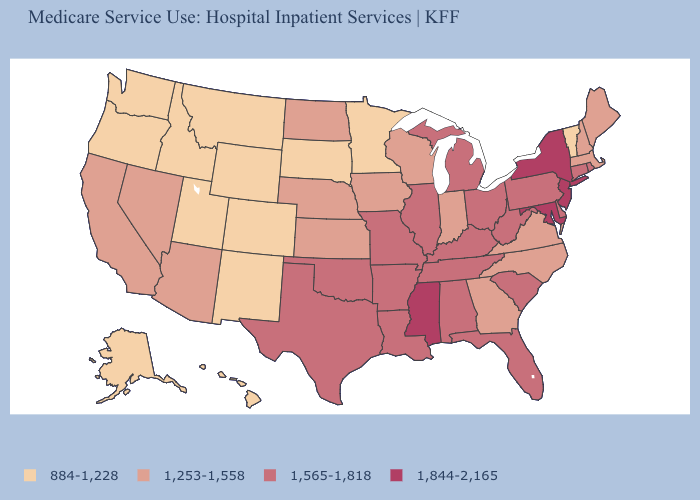How many symbols are there in the legend?
Be succinct. 4. Does Kansas have the lowest value in the MidWest?
Keep it brief. No. Is the legend a continuous bar?
Quick response, please. No. What is the highest value in the USA?
Keep it brief. 1,844-2,165. What is the value of South Dakota?
Write a very short answer. 884-1,228. Name the states that have a value in the range 1,844-2,165?
Concise answer only. Maryland, Mississippi, New Jersey, New York. Name the states that have a value in the range 1,253-1,558?
Short answer required. Arizona, California, Georgia, Indiana, Iowa, Kansas, Maine, Massachusetts, Nebraska, Nevada, New Hampshire, North Carolina, North Dakota, Virginia, Wisconsin. What is the lowest value in the Northeast?
Answer briefly. 884-1,228. What is the value of Arizona?
Concise answer only. 1,253-1,558. Does Utah have the lowest value in the USA?
Give a very brief answer. Yes. Which states have the lowest value in the USA?
Answer briefly. Alaska, Colorado, Hawaii, Idaho, Minnesota, Montana, New Mexico, Oregon, South Dakota, Utah, Vermont, Washington, Wyoming. Among the states that border Connecticut , does Massachusetts have the highest value?
Short answer required. No. What is the lowest value in the MidWest?
Quick response, please. 884-1,228. Name the states that have a value in the range 1,565-1,818?
Be succinct. Alabama, Arkansas, Connecticut, Delaware, Florida, Illinois, Kentucky, Louisiana, Michigan, Missouri, Ohio, Oklahoma, Pennsylvania, Rhode Island, South Carolina, Tennessee, Texas, West Virginia. 